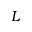<formula> <loc_0><loc_0><loc_500><loc_500>L</formula> 